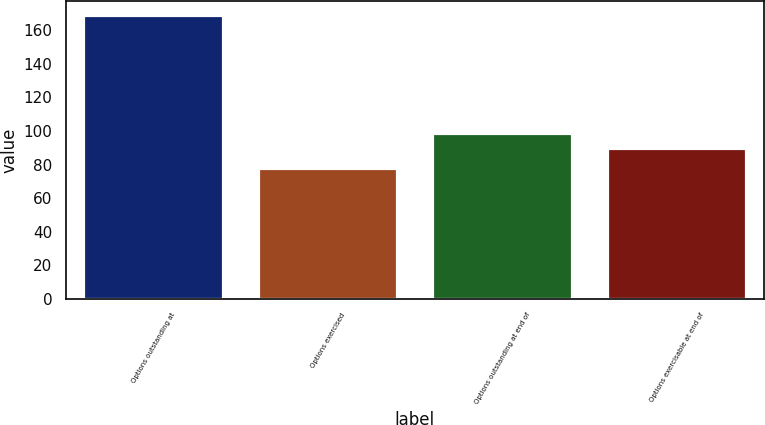Convert chart. <chart><loc_0><loc_0><loc_500><loc_500><bar_chart><fcel>Options outstanding at<fcel>Options exercised<fcel>Options outstanding at end of<fcel>Options exercisable at end of<nl><fcel>169<fcel>78<fcel>99.1<fcel>90<nl></chart> 